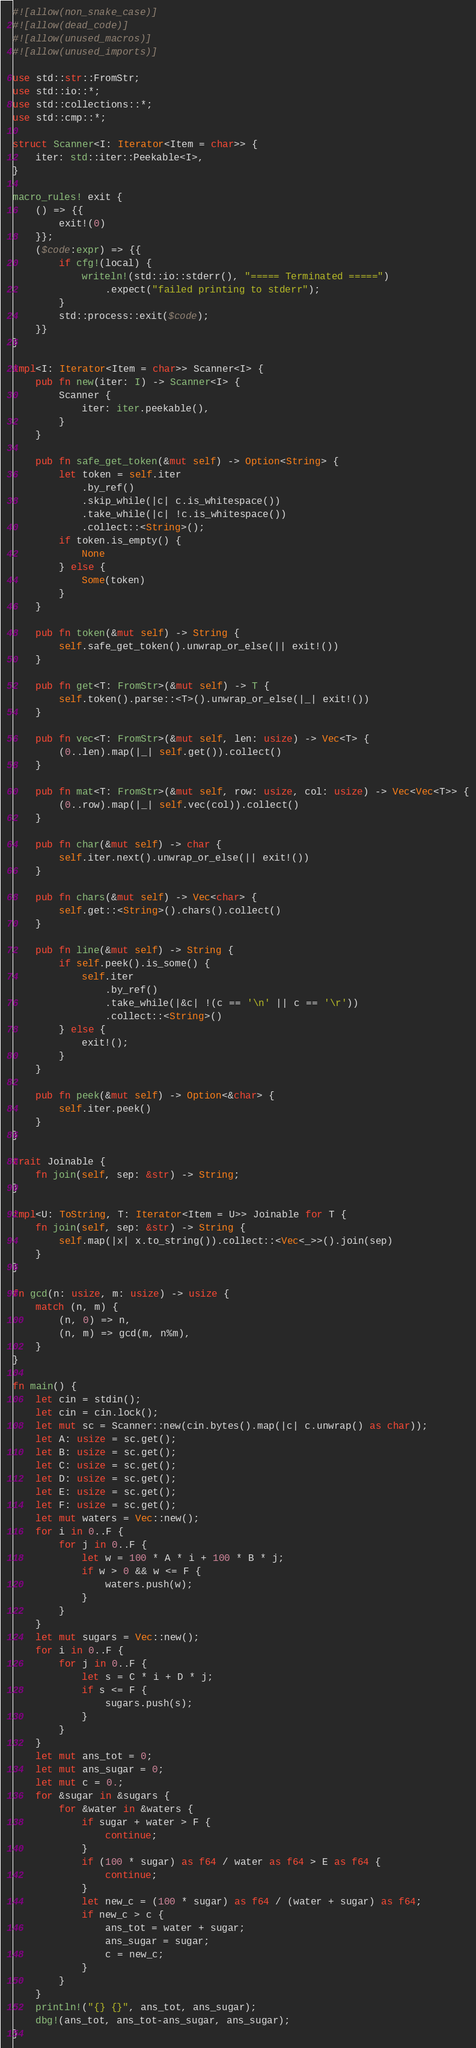Convert code to text. <code><loc_0><loc_0><loc_500><loc_500><_Rust_>#![allow(non_snake_case)]
#![allow(dead_code)]
#![allow(unused_macros)]
#![allow(unused_imports)]

use std::str::FromStr;
use std::io::*;
use std::collections::*;
use std::cmp::*;

struct Scanner<I: Iterator<Item = char>> {
    iter: std::iter::Peekable<I>,
}

macro_rules! exit {
    () => {{
        exit!(0)
    }};
    ($code:expr) => {{
        if cfg!(local) {
            writeln!(std::io::stderr(), "===== Terminated =====")
                .expect("failed printing to stderr");
        }
        std::process::exit($code);
    }}
}

impl<I: Iterator<Item = char>> Scanner<I> {
    pub fn new(iter: I) -> Scanner<I> {
        Scanner {
            iter: iter.peekable(),
        }
    }

    pub fn safe_get_token(&mut self) -> Option<String> {
        let token = self.iter
            .by_ref()
            .skip_while(|c| c.is_whitespace())
            .take_while(|c| !c.is_whitespace())
            .collect::<String>();
        if token.is_empty() {
            None
        } else {
            Some(token)
        }
    }

    pub fn token(&mut self) -> String {
        self.safe_get_token().unwrap_or_else(|| exit!())
    }

    pub fn get<T: FromStr>(&mut self) -> T {
        self.token().parse::<T>().unwrap_or_else(|_| exit!())
    }

    pub fn vec<T: FromStr>(&mut self, len: usize) -> Vec<T> {
        (0..len).map(|_| self.get()).collect()
    }

    pub fn mat<T: FromStr>(&mut self, row: usize, col: usize) -> Vec<Vec<T>> {
        (0..row).map(|_| self.vec(col)).collect()
    }

    pub fn char(&mut self) -> char {
        self.iter.next().unwrap_or_else(|| exit!())
    }

    pub fn chars(&mut self) -> Vec<char> {
        self.get::<String>().chars().collect()
    }

    pub fn line(&mut self) -> String {
        if self.peek().is_some() {
            self.iter
                .by_ref()
                .take_while(|&c| !(c == '\n' || c == '\r'))
                .collect::<String>()
        } else {
            exit!();
        }
    }

    pub fn peek(&mut self) -> Option<&char> {
        self.iter.peek()
    }
}

trait Joinable {
    fn join(self, sep: &str) -> String;
}

impl<U: ToString, T: Iterator<Item = U>> Joinable for T {
    fn join(self, sep: &str) -> String {
        self.map(|x| x.to_string()).collect::<Vec<_>>().join(sep)
    }
}

fn gcd(n: usize, m: usize) -> usize {
    match (n, m) {
        (n, 0) => n,
        (n, m) => gcd(m, n%m),
    }
}

fn main() {
    let cin = stdin();
    let cin = cin.lock();
    let mut sc = Scanner::new(cin.bytes().map(|c| c.unwrap() as char));
    let A: usize = sc.get();
    let B: usize = sc.get();
    let C: usize = sc.get();
    let D: usize = sc.get();
    let E: usize = sc.get();
    let F: usize = sc.get();
    let mut waters = Vec::new();
    for i in 0..F {
        for j in 0..F {
            let w = 100 * A * i + 100 * B * j;
            if w > 0 && w <= F {
                waters.push(w);
            }
        }
    }
    let mut sugars = Vec::new();
    for i in 0..F {
        for j in 0..F {
            let s = C * i + D * j;
            if s <= F {
                sugars.push(s);
            }
        }
    }
    let mut ans_tot = 0;
    let mut ans_sugar = 0;
    let mut c = 0.;
    for &sugar in &sugars {
        for &water in &waters {
            if sugar + water > F {
                continue;
            }
            if (100 * sugar) as f64 / water as f64 > E as f64 {
                continue;
            }
            let new_c = (100 * sugar) as f64 / (water + sugar) as f64;
            if new_c > c {
                ans_tot = water + sugar;
                ans_sugar = sugar;
                c = new_c;
            }
        }
    }
    println!("{} {}", ans_tot, ans_sugar);
    dbg!(ans_tot, ans_tot-ans_sugar, ans_sugar);
}
</code> 